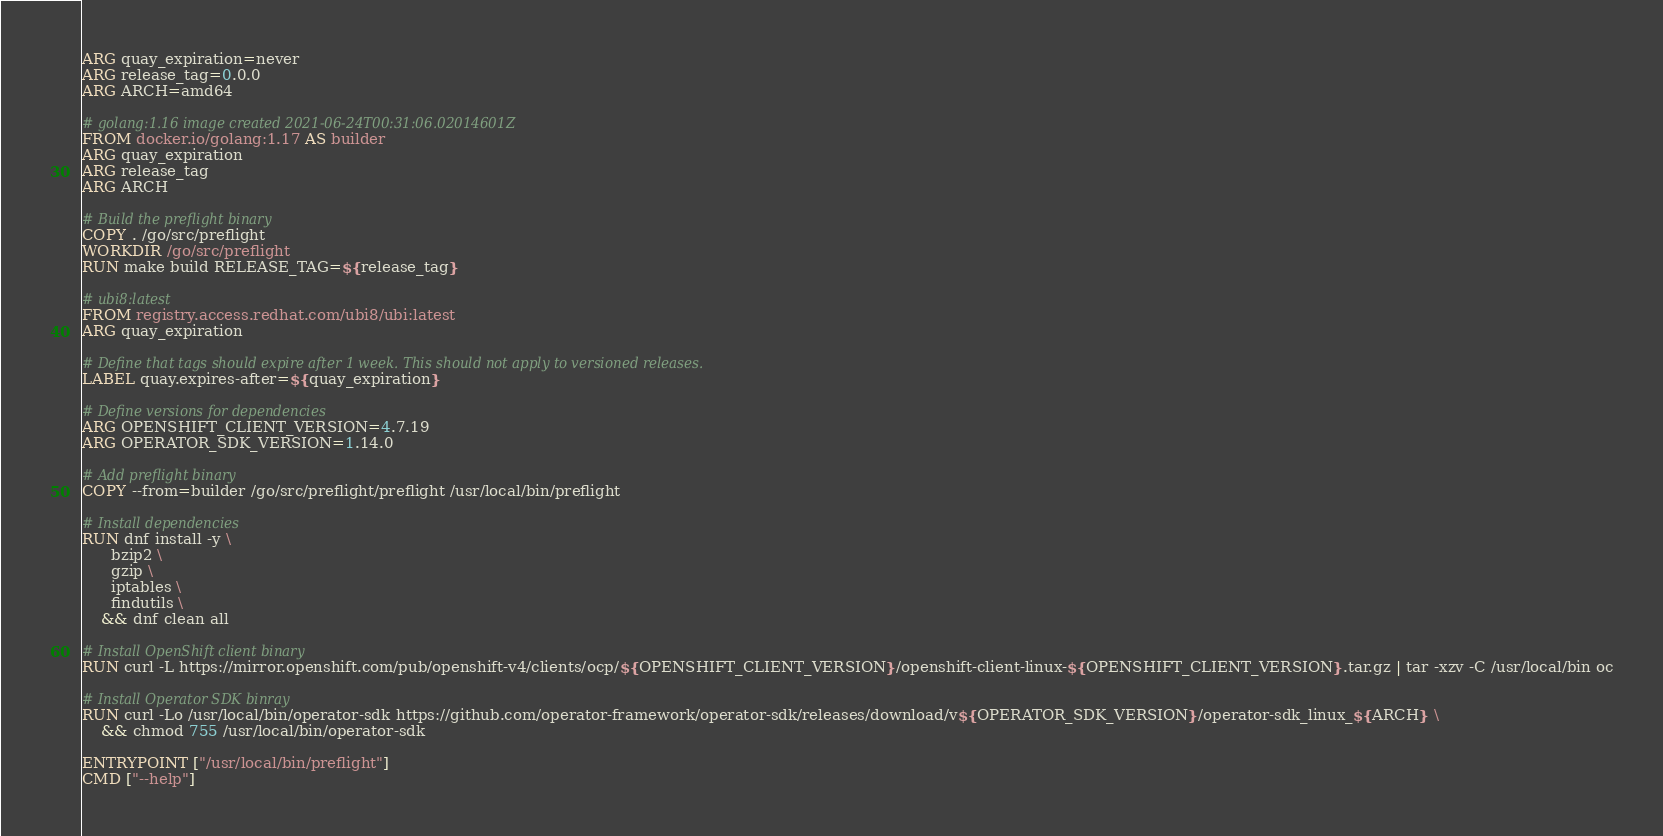<code> <loc_0><loc_0><loc_500><loc_500><_Dockerfile_>ARG quay_expiration=never
ARG release_tag=0.0.0
ARG ARCH=amd64

# golang:1.16 image created 2021-06-24T00:31:06.02014601Z 
FROM docker.io/golang:1.17 AS builder
ARG quay_expiration
ARG release_tag
ARG ARCH

# Build the preflight binary
COPY . /go/src/preflight
WORKDIR /go/src/preflight
RUN make build RELEASE_TAG=${release_tag}

# ubi8:latest
FROM registry.access.redhat.com/ubi8/ubi:latest
ARG quay_expiration

# Define that tags should expire after 1 week. This should not apply to versioned releases.
LABEL quay.expires-after=${quay_expiration}

# Define versions for dependencies
ARG OPENSHIFT_CLIENT_VERSION=4.7.19
ARG OPERATOR_SDK_VERSION=1.14.0

# Add preflight binary
COPY --from=builder /go/src/preflight/preflight /usr/local/bin/preflight

# Install dependencies
RUN dnf install -y \
      bzip2 \
      gzip \
      iptables \
      findutils \
    && dnf clean all

# Install OpenShift client binary
RUN curl -L https://mirror.openshift.com/pub/openshift-v4/clients/ocp/${OPENSHIFT_CLIENT_VERSION}/openshift-client-linux-${OPENSHIFT_CLIENT_VERSION}.tar.gz | tar -xzv -C /usr/local/bin oc

# Install Operator SDK binray
RUN curl -Lo /usr/local/bin/operator-sdk https://github.com/operator-framework/operator-sdk/releases/download/v${OPERATOR_SDK_VERSION}/operator-sdk_linux_${ARCH} \
    && chmod 755 /usr/local/bin/operator-sdk

ENTRYPOINT ["/usr/local/bin/preflight"]
CMD ["--help"]
</code> 